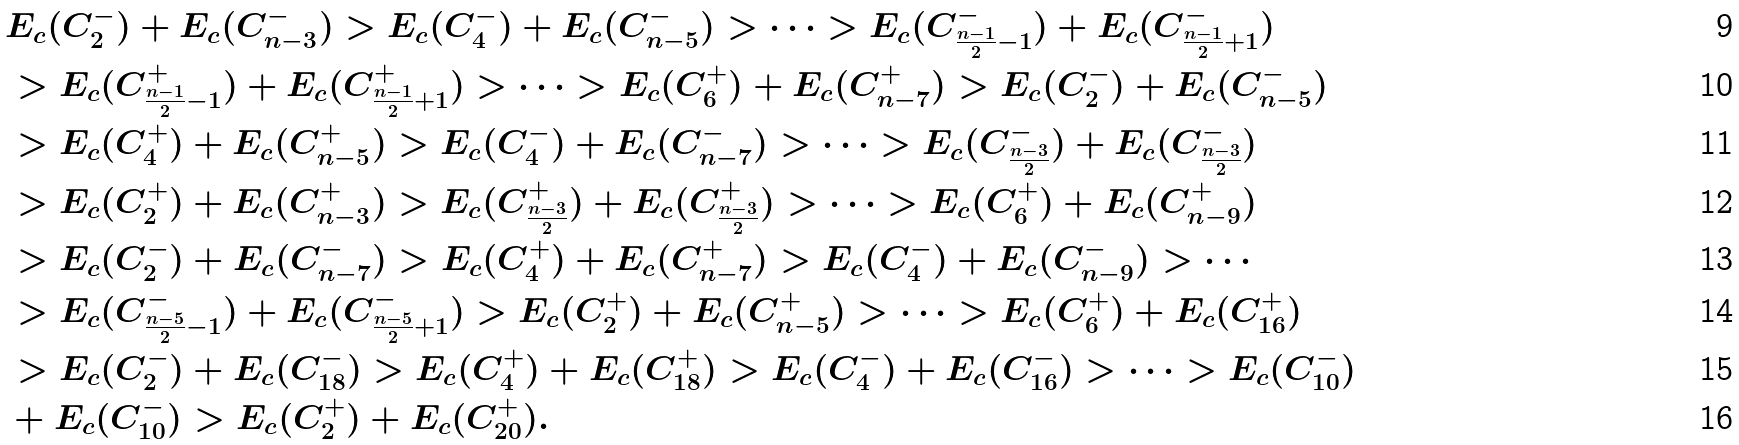Convert formula to latex. <formula><loc_0><loc_0><loc_500><loc_500>& E _ { c } ( C _ { 2 } ^ { - } ) + E _ { c } ( C _ { n - 3 } ^ { - } ) > E _ { c } ( C _ { 4 } ^ { - } ) + E _ { c } ( C _ { n - 5 } ^ { - } ) > \cdots > E _ { c } ( C _ { \frac { n - 1 } { 2 } - 1 } ^ { - } ) + E _ { c } ( C _ { \frac { n - 1 } { 2 } + 1 } ^ { - } ) \\ & > E _ { c } ( C _ { \frac { n - 1 } { 2 } - 1 } ^ { + } ) + E _ { c } ( C _ { \frac { n - 1 } { 2 } + 1 } ^ { + } ) > \cdots > E _ { c } ( C _ { 6 } ^ { + } ) + E _ { c } ( C _ { n - 7 } ^ { + } ) > E _ { c } ( C _ { 2 } ^ { - } ) + E _ { c } ( C _ { n - 5 } ^ { - } ) \\ & > E _ { c } ( C _ { 4 } ^ { + } ) + E _ { c } ( C _ { n - 5 } ^ { + } ) > E _ { c } ( C _ { 4 } ^ { - } ) + E _ { c } ( C _ { n - 7 } ^ { - } ) > \cdots > E _ { c } ( C _ { \frac { n - 3 } { 2 } } ^ { - } ) + E _ { c } ( C _ { \frac { n - 3 } { 2 } } ^ { - } ) \\ & > E _ { c } ( C _ { 2 } ^ { + } ) + E _ { c } ( C _ { n - 3 } ^ { + } ) > E _ { c } ( C _ { \frac { n - 3 } { 2 } } ^ { + } ) + E _ { c } ( C _ { \frac { n - 3 } { 2 } } ^ { + } ) > \cdots > E _ { c } ( C _ { 6 } ^ { + } ) + E _ { c } ( C _ { n - 9 } ^ { + } ) \\ & > E _ { c } ( C _ { 2 } ^ { - } ) + E _ { c } ( C _ { n - 7 } ^ { - } ) > E _ { c } ( C _ { 4 } ^ { + } ) + E _ { c } ( C _ { n - 7 } ^ { + } ) > E _ { c } ( C _ { 4 } ^ { - } ) + E _ { c } ( C _ { n - 9 } ^ { - } ) > \cdots \\ & > E _ { c } ( C _ { \frac { n - 5 } { 2 } - 1 } ^ { - } ) + E _ { c } ( C _ { \frac { n - 5 } { 2 } + 1 } ^ { - } ) > E _ { c } ( C _ { 2 } ^ { + } ) + E _ { c } ( C _ { n - 5 } ^ { + } ) > \cdots > E _ { c } ( C _ { 6 } ^ { + } ) + E _ { c } ( C _ { 1 6 } ^ { + } ) \\ & > E _ { c } ( C _ { 2 } ^ { - } ) + E _ { c } ( C _ { 1 8 } ^ { - } ) > E _ { c } ( C _ { 4 } ^ { + } ) + E _ { c } ( C _ { 1 8 } ^ { + } ) > E _ { c } ( C _ { 4 } ^ { - } ) + E _ { c } ( C _ { 1 6 } ^ { - } ) > \cdots > E _ { c } ( C _ { 1 0 } ^ { - } ) \\ & + E _ { c } ( C _ { 1 0 } ^ { - } ) > E _ { c } ( C _ { 2 } ^ { + } ) + E _ { c } ( C _ { 2 0 } ^ { + } ) .</formula> 